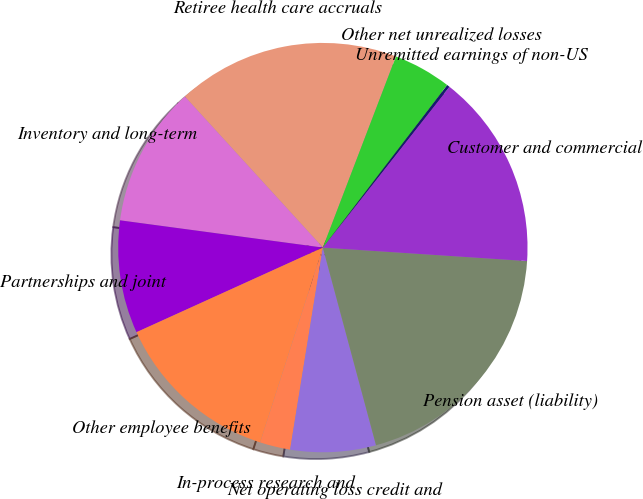<chart> <loc_0><loc_0><loc_500><loc_500><pie_chart><fcel>Retiree health care accruals<fcel>Inventory and long-term<fcel>Partnerships and joint<fcel>Other employee benefits<fcel>In-process research and<fcel>Net operating loss credit and<fcel>Pension asset (liability)<fcel>Customer and commercial<fcel>Unremitted earnings of non-US<fcel>Other net unrealized losses<nl><fcel>17.6%<fcel>11.09%<fcel>8.91%<fcel>13.26%<fcel>2.4%<fcel>6.74%<fcel>19.77%<fcel>15.43%<fcel>0.23%<fcel>4.57%<nl></chart> 